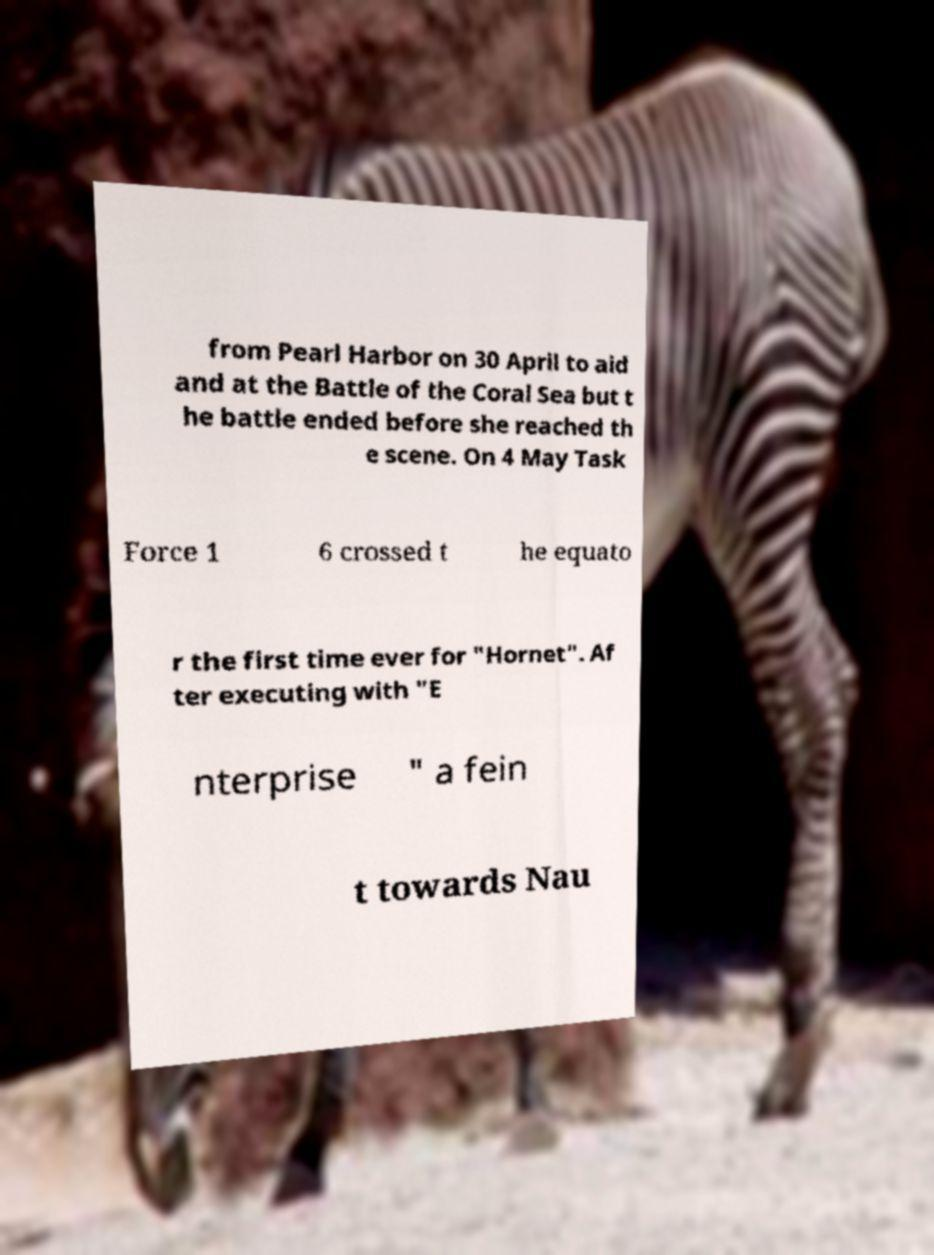Please read and relay the text visible in this image. What does it say? from Pearl Harbor on 30 April to aid and at the Battle of the Coral Sea but t he battle ended before she reached th e scene. On 4 May Task Force 1 6 crossed t he equato r the first time ever for "Hornet". Af ter executing with "E nterprise " a fein t towards Nau 